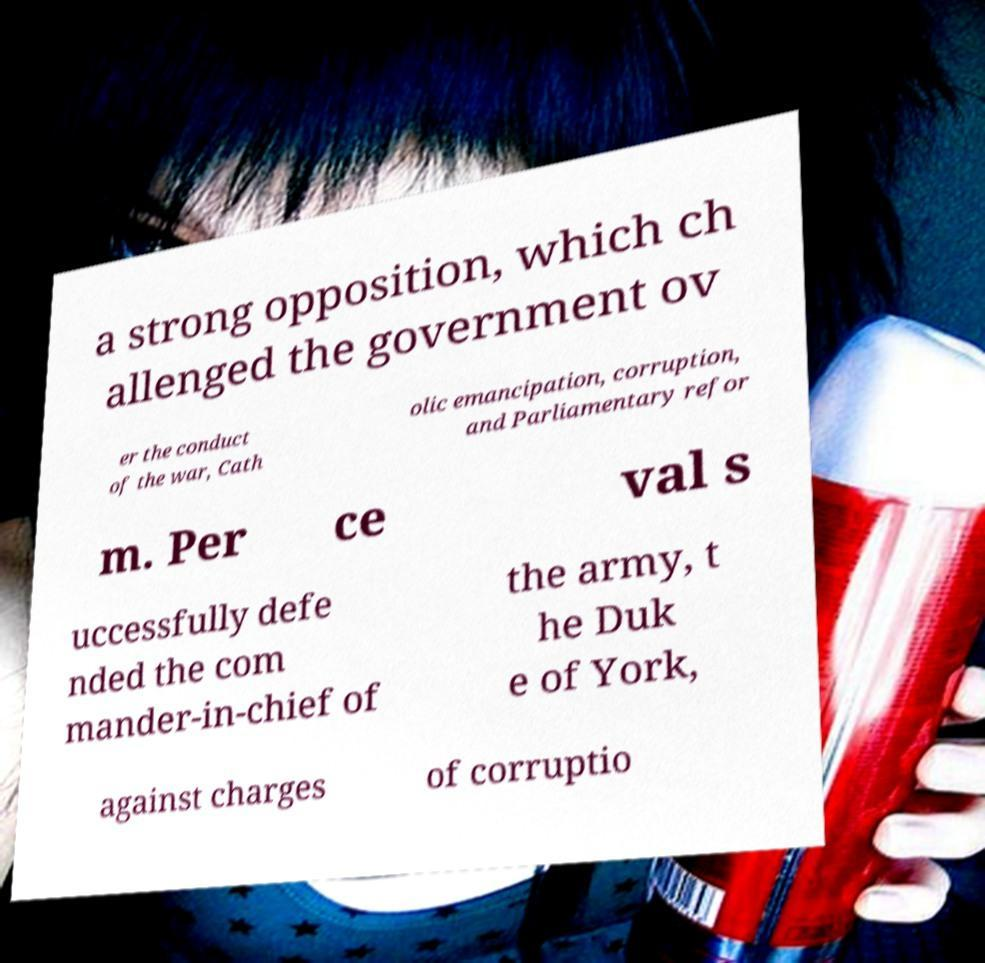Please read and relay the text visible in this image. What does it say? a strong opposition, which ch allenged the government ov er the conduct of the war, Cath olic emancipation, corruption, and Parliamentary refor m. Per ce val s uccessfully defe nded the com mander-in-chief of the army, t he Duk e of York, against charges of corruptio 